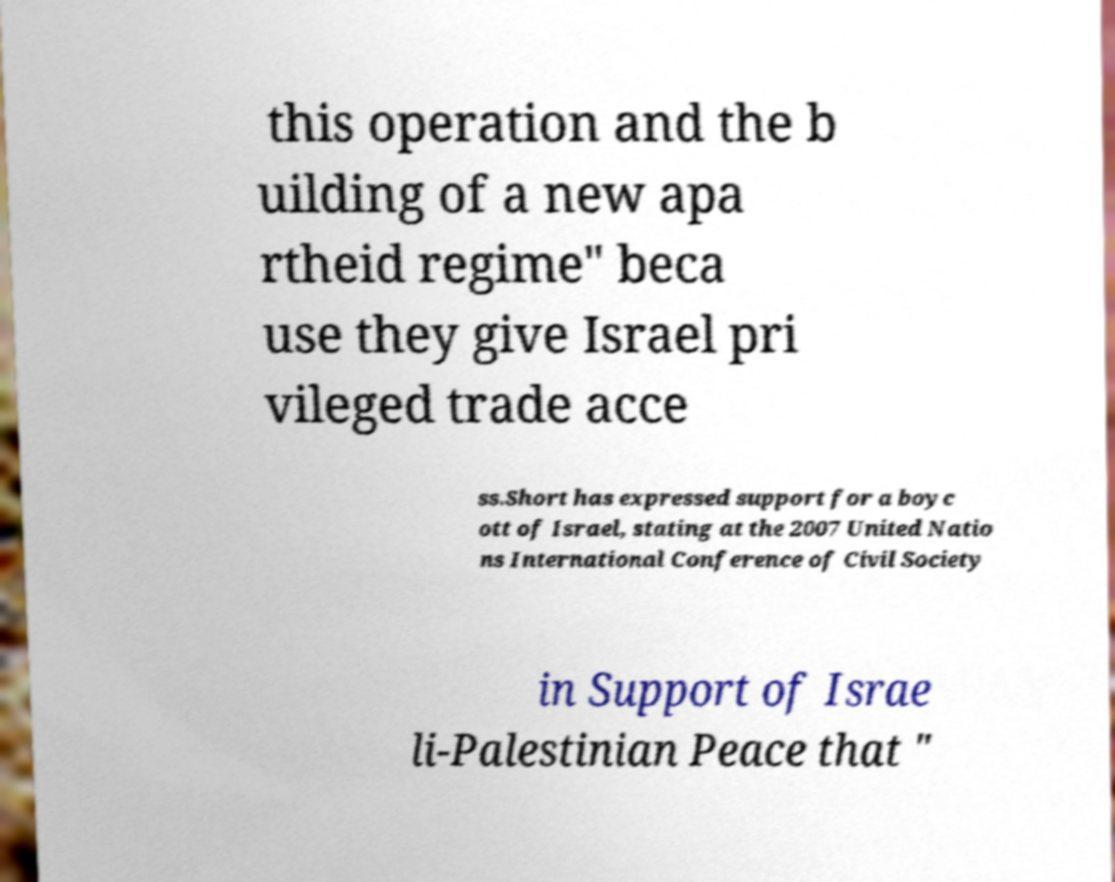Please read and relay the text visible in this image. What does it say? this operation and the b uilding of a new apa rtheid regime" beca use they give Israel pri vileged trade acce ss.Short has expressed support for a boyc ott of Israel, stating at the 2007 United Natio ns International Conference of Civil Society in Support of Israe li-Palestinian Peace that " 